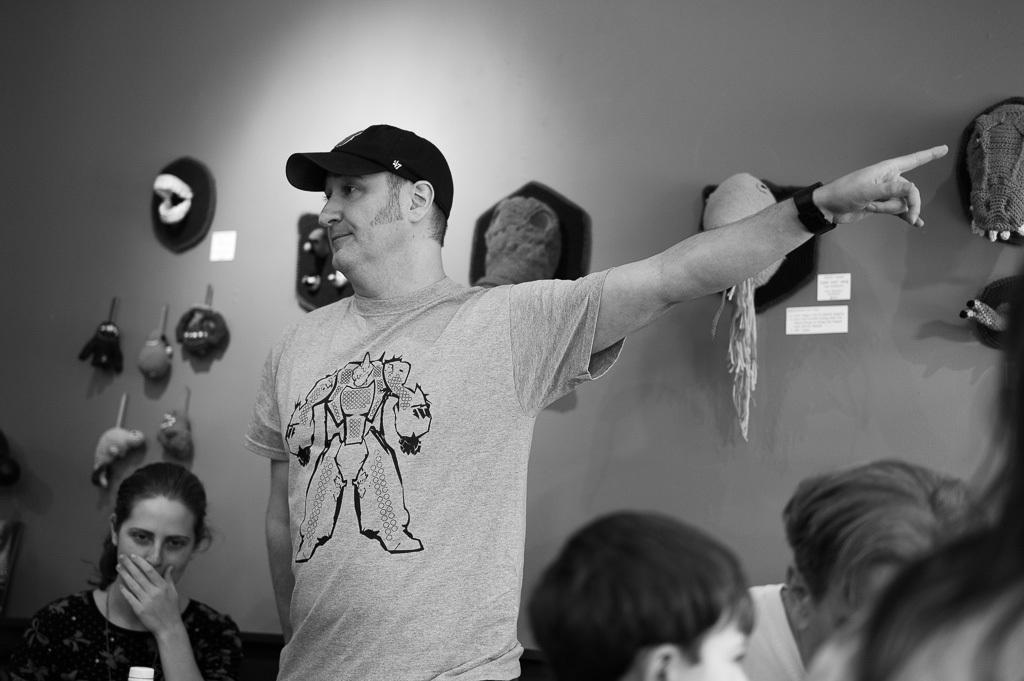Could you give a brief overview of what you see in this image? I can see this is a black and white picture. There are few people and in the background there is a wall. There are some objects hanged and attached to the wall. 